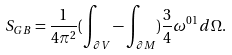Convert formula to latex. <formula><loc_0><loc_0><loc_500><loc_500>S _ { G B } = \frac { 1 } { 4 \pi ^ { 2 } } ( \int _ { \partial V } - \int _ { \partial M } ) \frac { 3 } { 4 } \omega ^ { 0 1 } d \Omega .</formula> 